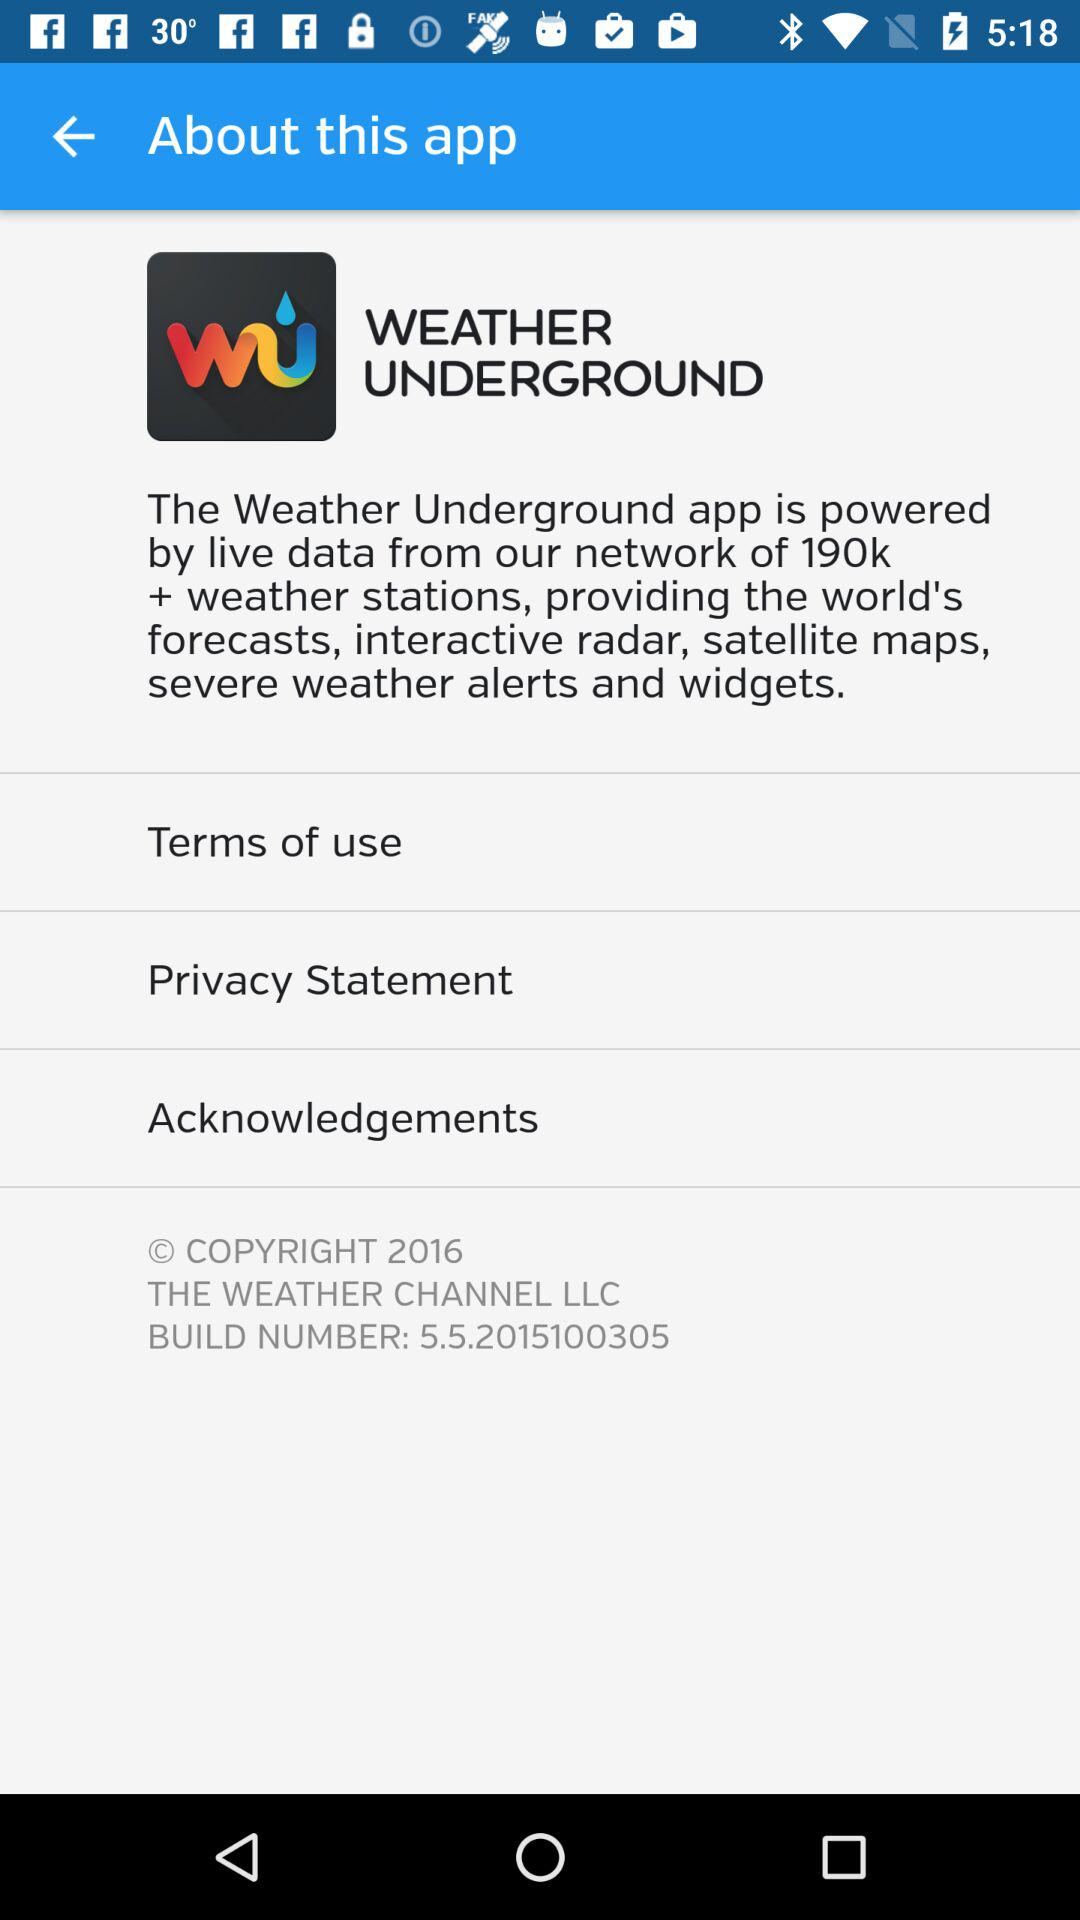What are the mentioned points in "about this app"? The mentioned points are: "The Weather Underground app is powered by live data from our network of 190k + weather stations, providing the world's forecasts, interactive radar, satellite maps, severe weather alerts and widgets.", "Terms of use", "Privacy Statement", and "Acknowledgements". 